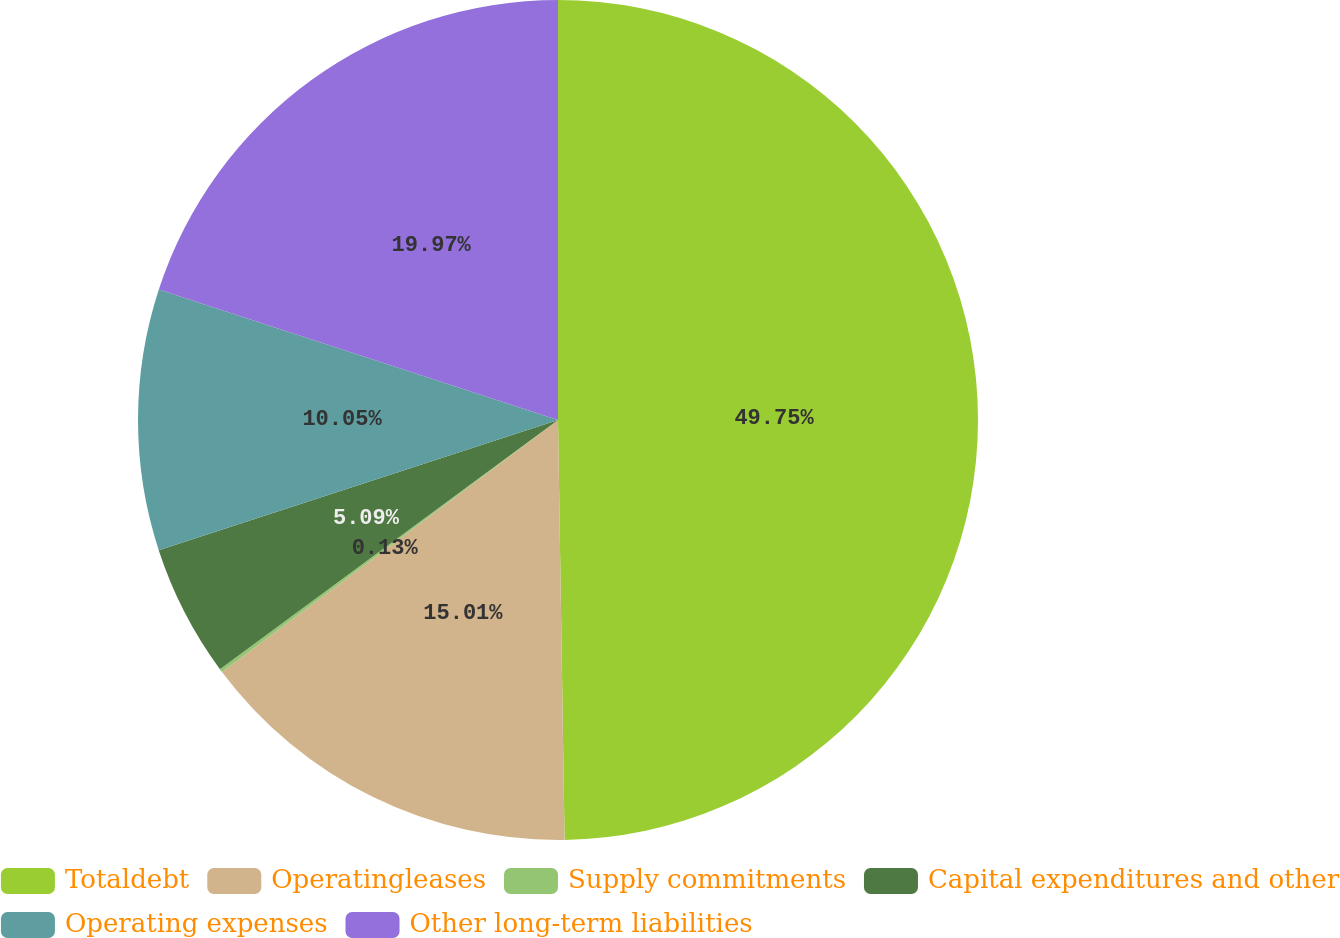<chart> <loc_0><loc_0><loc_500><loc_500><pie_chart><fcel>Totaldebt<fcel>Operatingleases<fcel>Supply commitments<fcel>Capital expenditures and other<fcel>Operating expenses<fcel>Other long-term liabilities<nl><fcel>49.75%<fcel>15.01%<fcel>0.13%<fcel>5.09%<fcel>10.05%<fcel>19.97%<nl></chart> 